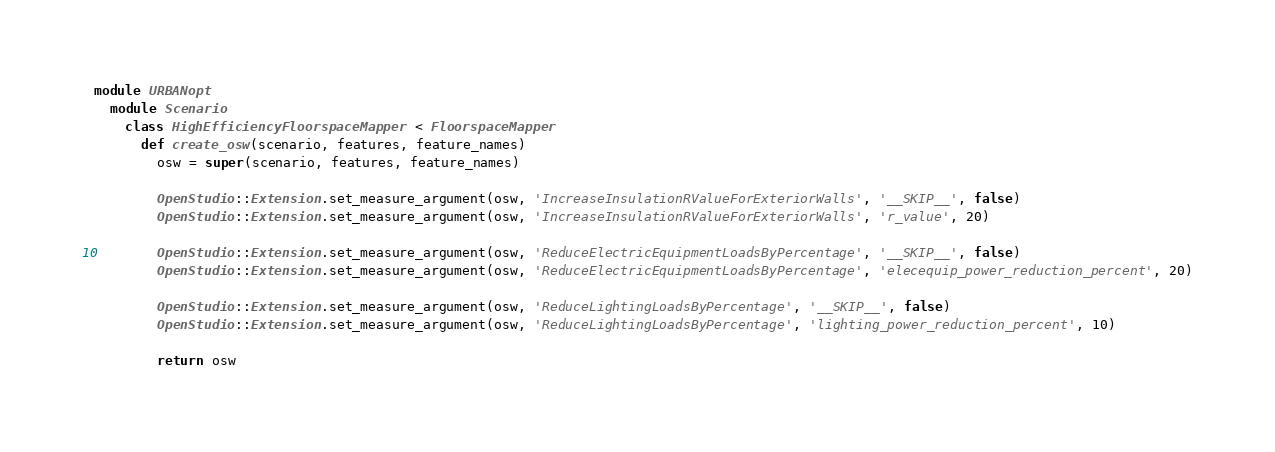<code> <loc_0><loc_0><loc_500><loc_500><_Ruby_>
module URBANopt
  module Scenario
    class HighEfficiencyFloorspaceMapper < FloorspaceMapper
      def create_osw(scenario, features, feature_names)
        osw = super(scenario, features, feature_names)

        OpenStudio::Extension.set_measure_argument(osw, 'IncreaseInsulationRValueForExteriorWalls', '__SKIP__', false)
        OpenStudio::Extension.set_measure_argument(osw, 'IncreaseInsulationRValueForExteriorWalls', 'r_value', 20)

        OpenStudio::Extension.set_measure_argument(osw, 'ReduceElectricEquipmentLoadsByPercentage', '__SKIP__', false)
        OpenStudio::Extension.set_measure_argument(osw, 'ReduceElectricEquipmentLoadsByPercentage', 'elecequip_power_reduction_percent', 20)

        OpenStudio::Extension.set_measure_argument(osw, 'ReduceLightingLoadsByPercentage', '__SKIP__', false)
        OpenStudio::Extension.set_measure_argument(osw, 'ReduceLightingLoadsByPercentage', 'lighting_power_reduction_percent', 10)

        return osw</code> 